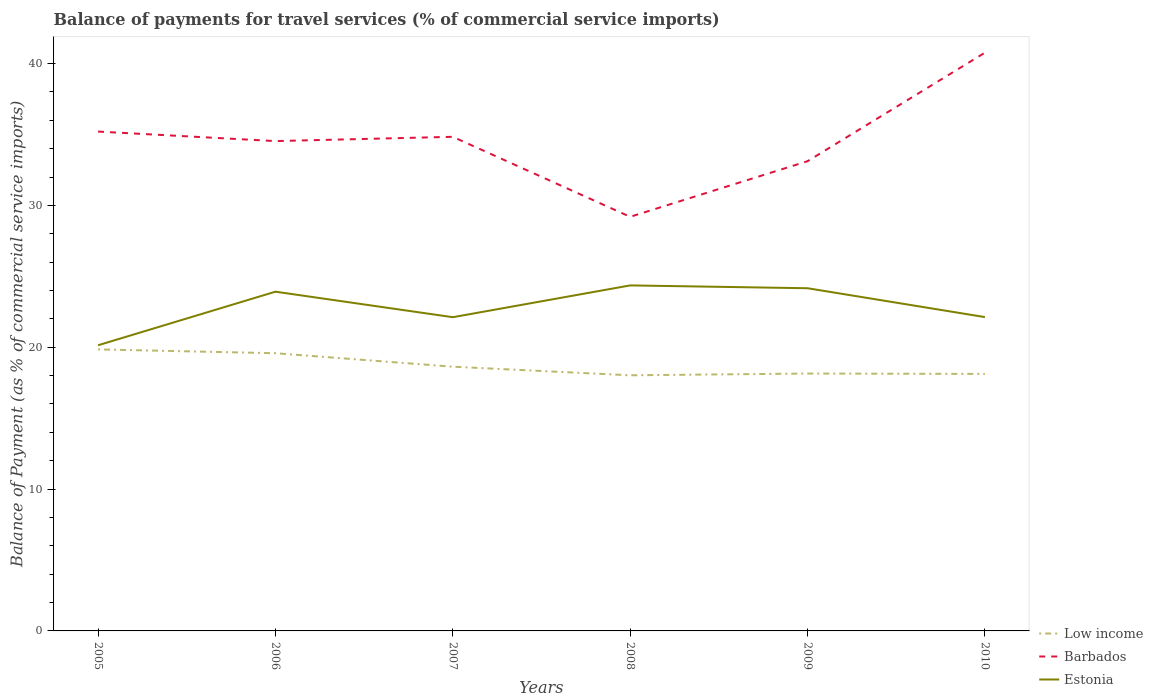How many different coloured lines are there?
Offer a terse response. 3. Across all years, what is the maximum balance of payments for travel services in Estonia?
Keep it short and to the point. 20.14. In which year was the balance of payments for travel services in Estonia maximum?
Your answer should be compact. 2005. What is the total balance of payments for travel services in Estonia in the graph?
Offer a very short reply. 0.2. What is the difference between the highest and the second highest balance of payments for travel services in Barbados?
Your answer should be compact. 11.57. What is the difference between the highest and the lowest balance of payments for travel services in Estonia?
Your response must be concise. 3. Is the balance of payments for travel services in Barbados strictly greater than the balance of payments for travel services in Estonia over the years?
Keep it short and to the point. No. What is the difference between two consecutive major ticks on the Y-axis?
Provide a short and direct response. 10. Are the values on the major ticks of Y-axis written in scientific E-notation?
Your answer should be compact. No. Does the graph contain any zero values?
Make the answer very short. No. Does the graph contain grids?
Your response must be concise. No. How many legend labels are there?
Your answer should be compact. 3. What is the title of the graph?
Give a very brief answer. Balance of payments for travel services (% of commercial service imports). Does "Mauritius" appear as one of the legend labels in the graph?
Make the answer very short. No. What is the label or title of the Y-axis?
Keep it short and to the point. Balance of Payment (as % of commercial service imports). What is the Balance of Payment (as % of commercial service imports) of Low income in 2005?
Your response must be concise. 19.85. What is the Balance of Payment (as % of commercial service imports) in Barbados in 2005?
Ensure brevity in your answer.  35.21. What is the Balance of Payment (as % of commercial service imports) of Estonia in 2005?
Your response must be concise. 20.14. What is the Balance of Payment (as % of commercial service imports) of Low income in 2006?
Your response must be concise. 19.58. What is the Balance of Payment (as % of commercial service imports) in Barbados in 2006?
Provide a short and direct response. 34.54. What is the Balance of Payment (as % of commercial service imports) in Estonia in 2006?
Offer a very short reply. 23.92. What is the Balance of Payment (as % of commercial service imports) in Low income in 2007?
Make the answer very short. 18.63. What is the Balance of Payment (as % of commercial service imports) in Barbados in 2007?
Offer a very short reply. 34.84. What is the Balance of Payment (as % of commercial service imports) in Estonia in 2007?
Provide a short and direct response. 22.12. What is the Balance of Payment (as % of commercial service imports) of Low income in 2008?
Keep it short and to the point. 18.02. What is the Balance of Payment (as % of commercial service imports) in Barbados in 2008?
Provide a succinct answer. 29.2. What is the Balance of Payment (as % of commercial service imports) of Estonia in 2008?
Keep it short and to the point. 24.36. What is the Balance of Payment (as % of commercial service imports) in Low income in 2009?
Make the answer very short. 18.15. What is the Balance of Payment (as % of commercial service imports) of Barbados in 2009?
Ensure brevity in your answer.  33.12. What is the Balance of Payment (as % of commercial service imports) in Estonia in 2009?
Your answer should be compact. 24.16. What is the Balance of Payment (as % of commercial service imports) in Low income in 2010?
Provide a succinct answer. 18.12. What is the Balance of Payment (as % of commercial service imports) in Barbados in 2010?
Provide a succinct answer. 40.77. What is the Balance of Payment (as % of commercial service imports) in Estonia in 2010?
Ensure brevity in your answer.  22.13. Across all years, what is the maximum Balance of Payment (as % of commercial service imports) in Low income?
Give a very brief answer. 19.85. Across all years, what is the maximum Balance of Payment (as % of commercial service imports) in Barbados?
Offer a terse response. 40.77. Across all years, what is the maximum Balance of Payment (as % of commercial service imports) of Estonia?
Give a very brief answer. 24.36. Across all years, what is the minimum Balance of Payment (as % of commercial service imports) in Low income?
Give a very brief answer. 18.02. Across all years, what is the minimum Balance of Payment (as % of commercial service imports) of Barbados?
Ensure brevity in your answer.  29.2. Across all years, what is the minimum Balance of Payment (as % of commercial service imports) in Estonia?
Your response must be concise. 20.14. What is the total Balance of Payment (as % of commercial service imports) of Low income in the graph?
Your answer should be compact. 112.35. What is the total Balance of Payment (as % of commercial service imports) of Barbados in the graph?
Offer a very short reply. 207.66. What is the total Balance of Payment (as % of commercial service imports) of Estonia in the graph?
Your answer should be very brief. 136.83. What is the difference between the Balance of Payment (as % of commercial service imports) of Low income in 2005 and that in 2006?
Your answer should be compact. 0.27. What is the difference between the Balance of Payment (as % of commercial service imports) in Barbados in 2005 and that in 2006?
Make the answer very short. 0.67. What is the difference between the Balance of Payment (as % of commercial service imports) of Estonia in 2005 and that in 2006?
Keep it short and to the point. -3.78. What is the difference between the Balance of Payment (as % of commercial service imports) in Low income in 2005 and that in 2007?
Your answer should be very brief. 1.22. What is the difference between the Balance of Payment (as % of commercial service imports) of Barbados in 2005 and that in 2007?
Your answer should be very brief. 0.37. What is the difference between the Balance of Payment (as % of commercial service imports) of Estonia in 2005 and that in 2007?
Keep it short and to the point. -1.98. What is the difference between the Balance of Payment (as % of commercial service imports) in Low income in 2005 and that in 2008?
Your answer should be very brief. 1.83. What is the difference between the Balance of Payment (as % of commercial service imports) of Barbados in 2005 and that in 2008?
Your answer should be very brief. 6.01. What is the difference between the Balance of Payment (as % of commercial service imports) of Estonia in 2005 and that in 2008?
Your answer should be compact. -4.22. What is the difference between the Balance of Payment (as % of commercial service imports) of Low income in 2005 and that in 2009?
Offer a very short reply. 1.7. What is the difference between the Balance of Payment (as % of commercial service imports) in Barbados in 2005 and that in 2009?
Ensure brevity in your answer.  2.09. What is the difference between the Balance of Payment (as % of commercial service imports) in Estonia in 2005 and that in 2009?
Provide a succinct answer. -4.02. What is the difference between the Balance of Payment (as % of commercial service imports) of Low income in 2005 and that in 2010?
Provide a succinct answer. 1.73. What is the difference between the Balance of Payment (as % of commercial service imports) of Barbados in 2005 and that in 2010?
Make the answer very short. -5.56. What is the difference between the Balance of Payment (as % of commercial service imports) in Estonia in 2005 and that in 2010?
Provide a succinct answer. -1.99. What is the difference between the Balance of Payment (as % of commercial service imports) in Low income in 2006 and that in 2007?
Your response must be concise. 0.95. What is the difference between the Balance of Payment (as % of commercial service imports) of Barbados in 2006 and that in 2007?
Make the answer very short. -0.3. What is the difference between the Balance of Payment (as % of commercial service imports) in Estonia in 2006 and that in 2007?
Your answer should be compact. 1.8. What is the difference between the Balance of Payment (as % of commercial service imports) of Low income in 2006 and that in 2008?
Provide a short and direct response. 1.56. What is the difference between the Balance of Payment (as % of commercial service imports) of Barbados in 2006 and that in 2008?
Offer a terse response. 5.34. What is the difference between the Balance of Payment (as % of commercial service imports) in Estonia in 2006 and that in 2008?
Offer a terse response. -0.44. What is the difference between the Balance of Payment (as % of commercial service imports) in Low income in 2006 and that in 2009?
Provide a succinct answer. 1.43. What is the difference between the Balance of Payment (as % of commercial service imports) of Barbados in 2006 and that in 2009?
Provide a short and direct response. 1.42. What is the difference between the Balance of Payment (as % of commercial service imports) of Estonia in 2006 and that in 2009?
Provide a succinct answer. -0.24. What is the difference between the Balance of Payment (as % of commercial service imports) of Low income in 2006 and that in 2010?
Provide a succinct answer. 1.46. What is the difference between the Balance of Payment (as % of commercial service imports) in Barbados in 2006 and that in 2010?
Provide a short and direct response. -6.23. What is the difference between the Balance of Payment (as % of commercial service imports) of Estonia in 2006 and that in 2010?
Offer a terse response. 1.79. What is the difference between the Balance of Payment (as % of commercial service imports) in Low income in 2007 and that in 2008?
Give a very brief answer. 0.61. What is the difference between the Balance of Payment (as % of commercial service imports) in Barbados in 2007 and that in 2008?
Keep it short and to the point. 5.64. What is the difference between the Balance of Payment (as % of commercial service imports) in Estonia in 2007 and that in 2008?
Offer a terse response. -2.24. What is the difference between the Balance of Payment (as % of commercial service imports) of Low income in 2007 and that in 2009?
Give a very brief answer. 0.48. What is the difference between the Balance of Payment (as % of commercial service imports) in Barbados in 2007 and that in 2009?
Your response must be concise. 1.72. What is the difference between the Balance of Payment (as % of commercial service imports) in Estonia in 2007 and that in 2009?
Provide a short and direct response. -2.04. What is the difference between the Balance of Payment (as % of commercial service imports) in Low income in 2007 and that in 2010?
Make the answer very short. 0.51. What is the difference between the Balance of Payment (as % of commercial service imports) in Barbados in 2007 and that in 2010?
Your response must be concise. -5.93. What is the difference between the Balance of Payment (as % of commercial service imports) in Estonia in 2007 and that in 2010?
Make the answer very short. -0.01. What is the difference between the Balance of Payment (as % of commercial service imports) of Low income in 2008 and that in 2009?
Your answer should be very brief. -0.12. What is the difference between the Balance of Payment (as % of commercial service imports) of Barbados in 2008 and that in 2009?
Provide a succinct answer. -3.92. What is the difference between the Balance of Payment (as % of commercial service imports) in Estonia in 2008 and that in 2009?
Your answer should be compact. 0.2. What is the difference between the Balance of Payment (as % of commercial service imports) of Low income in 2008 and that in 2010?
Make the answer very short. -0.1. What is the difference between the Balance of Payment (as % of commercial service imports) in Barbados in 2008 and that in 2010?
Give a very brief answer. -11.57. What is the difference between the Balance of Payment (as % of commercial service imports) in Estonia in 2008 and that in 2010?
Your answer should be very brief. 2.23. What is the difference between the Balance of Payment (as % of commercial service imports) in Low income in 2009 and that in 2010?
Ensure brevity in your answer.  0.03. What is the difference between the Balance of Payment (as % of commercial service imports) in Barbados in 2009 and that in 2010?
Give a very brief answer. -7.65. What is the difference between the Balance of Payment (as % of commercial service imports) of Estonia in 2009 and that in 2010?
Keep it short and to the point. 2.03. What is the difference between the Balance of Payment (as % of commercial service imports) of Low income in 2005 and the Balance of Payment (as % of commercial service imports) of Barbados in 2006?
Give a very brief answer. -14.69. What is the difference between the Balance of Payment (as % of commercial service imports) in Low income in 2005 and the Balance of Payment (as % of commercial service imports) in Estonia in 2006?
Make the answer very short. -4.07. What is the difference between the Balance of Payment (as % of commercial service imports) in Barbados in 2005 and the Balance of Payment (as % of commercial service imports) in Estonia in 2006?
Your answer should be compact. 11.29. What is the difference between the Balance of Payment (as % of commercial service imports) of Low income in 2005 and the Balance of Payment (as % of commercial service imports) of Barbados in 2007?
Offer a very short reply. -14.99. What is the difference between the Balance of Payment (as % of commercial service imports) in Low income in 2005 and the Balance of Payment (as % of commercial service imports) in Estonia in 2007?
Offer a very short reply. -2.27. What is the difference between the Balance of Payment (as % of commercial service imports) of Barbados in 2005 and the Balance of Payment (as % of commercial service imports) of Estonia in 2007?
Ensure brevity in your answer.  13.09. What is the difference between the Balance of Payment (as % of commercial service imports) in Low income in 2005 and the Balance of Payment (as % of commercial service imports) in Barbados in 2008?
Your response must be concise. -9.35. What is the difference between the Balance of Payment (as % of commercial service imports) of Low income in 2005 and the Balance of Payment (as % of commercial service imports) of Estonia in 2008?
Offer a terse response. -4.51. What is the difference between the Balance of Payment (as % of commercial service imports) of Barbados in 2005 and the Balance of Payment (as % of commercial service imports) of Estonia in 2008?
Give a very brief answer. 10.85. What is the difference between the Balance of Payment (as % of commercial service imports) in Low income in 2005 and the Balance of Payment (as % of commercial service imports) in Barbados in 2009?
Make the answer very short. -13.27. What is the difference between the Balance of Payment (as % of commercial service imports) in Low income in 2005 and the Balance of Payment (as % of commercial service imports) in Estonia in 2009?
Your answer should be very brief. -4.31. What is the difference between the Balance of Payment (as % of commercial service imports) in Barbados in 2005 and the Balance of Payment (as % of commercial service imports) in Estonia in 2009?
Your response must be concise. 11.05. What is the difference between the Balance of Payment (as % of commercial service imports) in Low income in 2005 and the Balance of Payment (as % of commercial service imports) in Barbados in 2010?
Keep it short and to the point. -20.92. What is the difference between the Balance of Payment (as % of commercial service imports) of Low income in 2005 and the Balance of Payment (as % of commercial service imports) of Estonia in 2010?
Ensure brevity in your answer.  -2.28. What is the difference between the Balance of Payment (as % of commercial service imports) of Barbados in 2005 and the Balance of Payment (as % of commercial service imports) of Estonia in 2010?
Provide a short and direct response. 13.08. What is the difference between the Balance of Payment (as % of commercial service imports) of Low income in 2006 and the Balance of Payment (as % of commercial service imports) of Barbados in 2007?
Provide a succinct answer. -15.26. What is the difference between the Balance of Payment (as % of commercial service imports) in Low income in 2006 and the Balance of Payment (as % of commercial service imports) in Estonia in 2007?
Your response must be concise. -2.54. What is the difference between the Balance of Payment (as % of commercial service imports) of Barbados in 2006 and the Balance of Payment (as % of commercial service imports) of Estonia in 2007?
Provide a short and direct response. 12.42. What is the difference between the Balance of Payment (as % of commercial service imports) of Low income in 2006 and the Balance of Payment (as % of commercial service imports) of Barbados in 2008?
Give a very brief answer. -9.62. What is the difference between the Balance of Payment (as % of commercial service imports) in Low income in 2006 and the Balance of Payment (as % of commercial service imports) in Estonia in 2008?
Provide a succinct answer. -4.78. What is the difference between the Balance of Payment (as % of commercial service imports) of Barbados in 2006 and the Balance of Payment (as % of commercial service imports) of Estonia in 2008?
Keep it short and to the point. 10.17. What is the difference between the Balance of Payment (as % of commercial service imports) in Low income in 2006 and the Balance of Payment (as % of commercial service imports) in Barbados in 2009?
Offer a terse response. -13.54. What is the difference between the Balance of Payment (as % of commercial service imports) of Low income in 2006 and the Balance of Payment (as % of commercial service imports) of Estonia in 2009?
Your answer should be compact. -4.58. What is the difference between the Balance of Payment (as % of commercial service imports) in Barbados in 2006 and the Balance of Payment (as % of commercial service imports) in Estonia in 2009?
Provide a succinct answer. 10.37. What is the difference between the Balance of Payment (as % of commercial service imports) in Low income in 2006 and the Balance of Payment (as % of commercial service imports) in Barbados in 2010?
Your response must be concise. -21.19. What is the difference between the Balance of Payment (as % of commercial service imports) of Low income in 2006 and the Balance of Payment (as % of commercial service imports) of Estonia in 2010?
Keep it short and to the point. -2.55. What is the difference between the Balance of Payment (as % of commercial service imports) of Barbados in 2006 and the Balance of Payment (as % of commercial service imports) of Estonia in 2010?
Offer a terse response. 12.41. What is the difference between the Balance of Payment (as % of commercial service imports) in Low income in 2007 and the Balance of Payment (as % of commercial service imports) in Barbados in 2008?
Ensure brevity in your answer.  -10.57. What is the difference between the Balance of Payment (as % of commercial service imports) in Low income in 2007 and the Balance of Payment (as % of commercial service imports) in Estonia in 2008?
Your answer should be compact. -5.73. What is the difference between the Balance of Payment (as % of commercial service imports) in Barbados in 2007 and the Balance of Payment (as % of commercial service imports) in Estonia in 2008?
Provide a succinct answer. 10.48. What is the difference between the Balance of Payment (as % of commercial service imports) of Low income in 2007 and the Balance of Payment (as % of commercial service imports) of Barbados in 2009?
Provide a succinct answer. -14.49. What is the difference between the Balance of Payment (as % of commercial service imports) of Low income in 2007 and the Balance of Payment (as % of commercial service imports) of Estonia in 2009?
Give a very brief answer. -5.53. What is the difference between the Balance of Payment (as % of commercial service imports) of Barbados in 2007 and the Balance of Payment (as % of commercial service imports) of Estonia in 2009?
Offer a terse response. 10.68. What is the difference between the Balance of Payment (as % of commercial service imports) of Low income in 2007 and the Balance of Payment (as % of commercial service imports) of Barbados in 2010?
Offer a very short reply. -22.14. What is the difference between the Balance of Payment (as % of commercial service imports) of Low income in 2007 and the Balance of Payment (as % of commercial service imports) of Estonia in 2010?
Offer a very short reply. -3.5. What is the difference between the Balance of Payment (as % of commercial service imports) of Barbados in 2007 and the Balance of Payment (as % of commercial service imports) of Estonia in 2010?
Make the answer very short. 12.71. What is the difference between the Balance of Payment (as % of commercial service imports) in Low income in 2008 and the Balance of Payment (as % of commercial service imports) in Barbados in 2009?
Provide a short and direct response. -15.09. What is the difference between the Balance of Payment (as % of commercial service imports) of Low income in 2008 and the Balance of Payment (as % of commercial service imports) of Estonia in 2009?
Offer a terse response. -6.14. What is the difference between the Balance of Payment (as % of commercial service imports) of Barbados in 2008 and the Balance of Payment (as % of commercial service imports) of Estonia in 2009?
Offer a very short reply. 5.04. What is the difference between the Balance of Payment (as % of commercial service imports) in Low income in 2008 and the Balance of Payment (as % of commercial service imports) in Barbados in 2010?
Your answer should be very brief. -22.74. What is the difference between the Balance of Payment (as % of commercial service imports) of Low income in 2008 and the Balance of Payment (as % of commercial service imports) of Estonia in 2010?
Your answer should be compact. -4.1. What is the difference between the Balance of Payment (as % of commercial service imports) in Barbados in 2008 and the Balance of Payment (as % of commercial service imports) in Estonia in 2010?
Offer a terse response. 7.07. What is the difference between the Balance of Payment (as % of commercial service imports) in Low income in 2009 and the Balance of Payment (as % of commercial service imports) in Barbados in 2010?
Your response must be concise. -22.62. What is the difference between the Balance of Payment (as % of commercial service imports) in Low income in 2009 and the Balance of Payment (as % of commercial service imports) in Estonia in 2010?
Offer a terse response. -3.98. What is the difference between the Balance of Payment (as % of commercial service imports) of Barbados in 2009 and the Balance of Payment (as % of commercial service imports) of Estonia in 2010?
Make the answer very short. 10.99. What is the average Balance of Payment (as % of commercial service imports) of Low income per year?
Provide a short and direct response. 18.72. What is the average Balance of Payment (as % of commercial service imports) of Barbados per year?
Your answer should be very brief. 34.61. What is the average Balance of Payment (as % of commercial service imports) in Estonia per year?
Offer a very short reply. 22.8. In the year 2005, what is the difference between the Balance of Payment (as % of commercial service imports) of Low income and Balance of Payment (as % of commercial service imports) of Barbados?
Your answer should be compact. -15.36. In the year 2005, what is the difference between the Balance of Payment (as % of commercial service imports) of Low income and Balance of Payment (as % of commercial service imports) of Estonia?
Your answer should be very brief. -0.29. In the year 2005, what is the difference between the Balance of Payment (as % of commercial service imports) of Barbados and Balance of Payment (as % of commercial service imports) of Estonia?
Your answer should be compact. 15.07. In the year 2006, what is the difference between the Balance of Payment (as % of commercial service imports) of Low income and Balance of Payment (as % of commercial service imports) of Barbados?
Your response must be concise. -14.96. In the year 2006, what is the difference between the Balance of Payment (as % of commercial service imports) of Low income and Balance of Payment (as % of commercial service imports) of Estonia?
Keep it short and to the point. -4.34. In the year 2006, what is the difference between the Balance of Payment (as % of commercial service imports) of Barbados and Balance of Payment (as % of commercial service imports) of Estonia?
Offer a very short reply. 10.62. In the year 2007, what is the difference between the Balance of Payment (as % of commercial service imports) in Low income and Balance of Payment (as % of commercial service imports) in Barbados?
Provide a succinct answer. -16.21. In the year 2007, what is the difference between the Balance of Payment (as % of commercial service imports) in Low income and Balance of Payment (as % of commercial service imports) in Estonia?
Your answer should be very brief. -3.49. In the year 2007, what is the difference between the Balance of Payment (as % of commercial service imports) in Barbados and Balance of Payment (as % of commercial service imports) in Estonia?
Your answer should be very brief. 12.72. In the year 2008, what is the difference between the Balance of Payment (as % of commercial service imports) of Low income and Balance of Payment (as % of commercial service imports) of Barbados?
Offer a terse response. -11.17. In the year 2008, what is the difference between the Balance of Payment (as % of commercial service imports) in Low income and Balance of Payment (as % of commercial service imports) in Estonia?
Give a very brief answer. -6.34. In the year 2008, what is the difference between the Balance of Payment (as % of commercial service imports) in Barbados and Balance of Payment (as % of commercial service imports) in Estonia?
Offer a terse response. 4.84. In the year 2009, what is the difference between the Balance of Payment (as % of commercial service imports) in Low income and Balance of Payment (as % of commercial service imports) in Barbados?
Your answer should be very brief. -14.97. In the year 2009, what is the difference between the Balance of Payment (as % of commercial service imports) of Low income and Balance of Payment (as % of commercial service imports) of Estonia?
Make the answer very short. -6.01. In the year 2009, what is the difference between the Balance of Payment (as % of commercial service imports) in Barbados and Balance of Payment (as % of commercial service imports) in Estonia?
Your answer should be compact. 8.95. In the year 2010, what is the difference between the Balance of Payment (as % of commercial service imports) of Low income and Balance of Payment (as % of commercial service imports) of Barbados?
Provide a succinct answer. -22.65. In the year 2010, what is the difference between the Balance of Payment (as % of commercial service imports) of Low income and Balance of Payment (as % of commercial service imports) of Estonia?
Provide a short and direct response. -4.01. In the year 2010, what is the difference between the Balance of Payment (as % of commercial service imports) of Barbados and Balance of Payment (as % of commercial service imports) of Estonia?
Offer a very short reply. 18.64. What is the ratio of the Balance of Payment (as % of commercial service imports) in Low income in 2005 to that in 2006?
Offer a very short reply. 1.01. What is the ratio of the Balance of Payment (as % of commercial service imports) in Barbados in 2005 to that in 2006?
Ensure brevity in your answer.  1.02. What is the ratio of the Balance of Payment (as % of commercial service imports) of Estonia in 2005 to that in 2006?
Your answer should be very brief. 0.84. What is the ratio of the Balance of Payment (as % of commercial service imports) of Low income in 2005 to that in 2007?
Provide a short and direct response. 1.07. What is the ratio of the Balance of Payment (as % of commercial service imports) of Barbados in 2005 to that in 2007?
Offer a terse response. 1.01. What is the ratio of the Balance of Payment (as % of commercial service imports) of Estonia in 2005 to that in 2007?
Offer a terse response. 0.91. What is the ratio of the Balance of Payment (as % of commercial service imports) of Low income in 2005 to that in 2008?
Ensure brevity in your answer.  1.1. What is the ratio of the Balance of Payment (as % of commercial service imports) in Barbados in 2005 to that in 2008?
Give a very brief answer. 1.21. What is the ratio of the Balance of Payment (as % of commercial service imports) of Estonia in 2005 to that in 2008?
Ensure brevity in your answer.  0.83. What is the ratio of the Balance of Payment (as % of commercial service imports) of Low income in 2005 to that in 2009?
Your answer should be very brief. 1.09. What is the ratio of the Balance of Payment (as % of commercial service imports) of Barbados in 2005 to that in 2009?
Offer a very short reply. 1.06. What is the ratio of the Balance of Payment (as % of commercial service imports) of Estonia in 2005 to that in 2009?
Keep it short and to the point. 0.83. What is the ratio of the Balance of Payment (as % of commercial service imports) in Low income in 2005 to that in 2010?
Your answer should be compact. 1.1. What is the ratio of the Balance of Payment (as % of commercial service imports) in Barbados in 2005 to that in 2010?
Offer a very short reply. 0.86. What is the ratio of the Balance of Payment (as % of commercial service imports) in Estonia in 2005 to that in 2010?
Offer a terse response. 0.91. What is the ratio of the Balance of Payment (as % of commercial service imports) of Low income in 2006 to that in 2007?
Make the answer very short. 1.05. What is the ratio of the Balance of Payment (as % of commercial service imports) of Barbados in 2006 to that in 2007?
Your answer should be very brief. 0.99. What is the ratio of the Balance of Payment (as % of commercial service imports) in Estonia in 2006 to that in 2007?
Your answer should be compact. 1.08. What is the ratio of the Balance of Payment (as % of commercial service imports) in Low income in 2006 to that in 2008?
Offer a very short reply. 1.09. What is the ratio of the Balance of Payment (as % of commercial service imports) of Barbados in 2006 to that in 2008?
Provide a succinct answer. 1.18. What is the ratio of the Balance of Payment (as % of commercial service imports) of Estonia in 2006 to that in 2008?
Provide a succinct answer. 0.98. What is the ratio of the Balance of Payment (as % of commercial service imports) of Low income in 2006 to that in 2009?
Ensure brevity in your answer.  1.08. What is the ratio of the Balance of Payment (as % of commercial service imports) of Barbados in 2006 to that in 2009?
Offer a very short reply. 1.04. What is the ratio of the Balance of Payment (as % of commercial service imports) in Low income in 2006 to that in 2010?
Offer a terse response. 1.08. What is the ratio of the Balance of Payment (as % of commercial service imports) in Barbados in 2006 to that in 2010?
Ensure brevity in your answer.  0.85. What is the ratio of the Balance of Payment (as % of commercial service imports) in Estonia in 2006 to that in 2010?
Offer a terse response. 1.08. What is the ratio of the Balance of Payment (as % of commercial service imports) of Low income in 2007 to that in 2008?
Offer a very short reply. 1.03. What is the ratio of the Balance of Payment (as % of commercial service imports) of Barbados in 2007 to that in 2008?
Your answer should be very brief. 1.19. What is the ratio of the Balance of Payment (as % of commercial service imports) of Estonia in 2007 to that in 2008?
Give a very brief answer. 0.91. What is the ratio of the Balance of Payment (as % of commercial service imports) of Low income in 2007 to that in 2009?
Provide a short and direct response. 1.03. What is the ratio of the Balance of Payment (as % of commercial service imports) of Barbados in 2007 to that in 2009?
Your response must be concise. 1.05. What is the ratio of the Balance of Payment (as % of commercial service imports) of Estonia in 2007 to that in 2009?
Give a very brief answer. 0.92. What is the ratio of the Balance of Payment (as % of commercial service imports) in Low income in 2007 to that in 2010?
Your answer should be compact. 1.03. What is the ratio of the Balance of Payment (as % of commercial service imports) in Barbados in 2007 to that in 2010?
Give a very brief answer. 0.85. What is the ratio of the Balance of Payment (as % of commercial service imports) of Estonia in 2007 to that in 2010?
Provide a succinct answer. 1. What is the ratio of the Balance of Payment (as % of commercial service imports) in Barbados in 2008 to that in 2009?
Ensure brevity in your answer.  0.88. What is the ratio of the Balance of Payment (as % of commercial service imports) of Estonia in 2008 to that in 2009?
Make the answer very short. 1.01. What is the ratio of the Balance of Payment (as % of commercial service imports) of Barbados in 2008 to that in 2010?
Your answer should be very brief. 0.72. What is the ratio of the Balance of Payment (as % of commercial service imports) in Estonia in 2008 to that in 2010?
Your answer should be compact. 1.1. What is the ratio of the Balance of Payment (as % of commercial service imports) of Low income in 2009 to that in 2010?
Ensure brevity in your answer.  1. What is the ratio of the Balance of Payment (as % of commercial service imports) in Barbados in 2009 to that in 2010?
Give a very brief answer. 0.81. What is the ratio of the Balance of Payment (as % of commercial service imports) of Estonia in 2009 to that in 2010?
Provide a succinct answer. 1.09. What is the difference between the highest and the second highest Balance of Payment (as % of commercial service imports) in Low income?
Offer a very short reply. 0.27. What is the difference between the highest and the second highest Balance of Payment (as % of commercial service imports) of Barbados?
Make the answer very short. 5.56. What is the difference between the highest and the second highest Balance of Payment (as % of commercial service imports) of Estonia?
Provide a succinct answer. 0.2. What is the difference between the highest and the lowest Balance of Payment (as % of commercial service imports) of Low income?
Provide a short and direct response. 1.83. What is the difference between the highest and the lowest Balance of Payment (as % of commercial service imports) of Barbados?
Make the answer very short. 11.57. What is the difference between the highest and the lowest Balance of Payment (as % of commercial service imports) in Estonia?
Offer a very short reply. 4.22. 